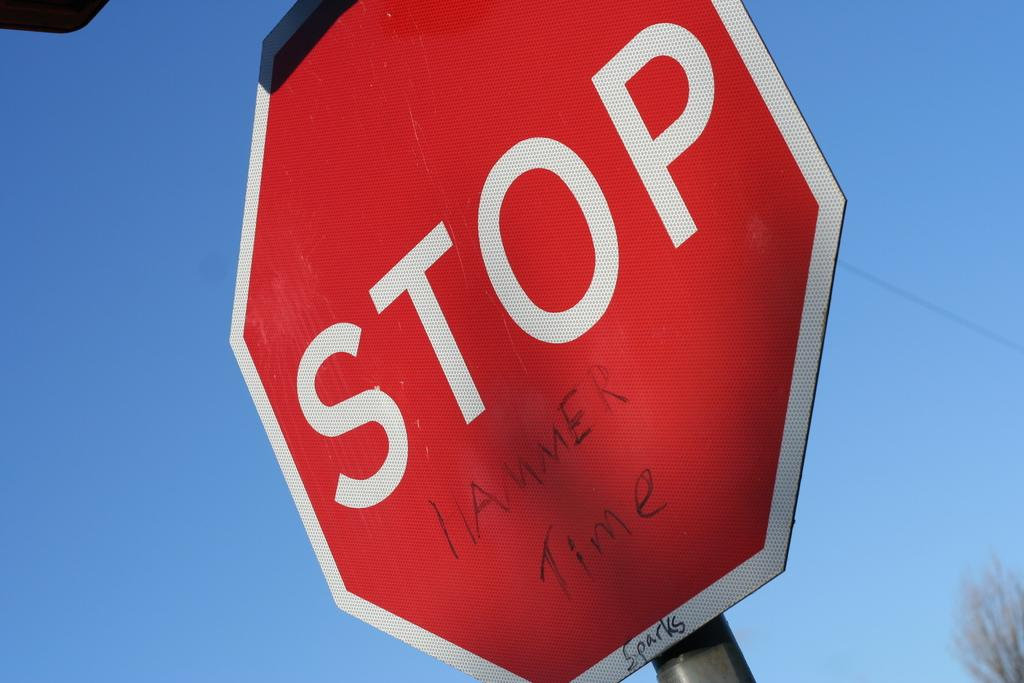<image>
Create a compact narrative representing the image presented. A STOP sign with graffiti etched underneath that says Hammer Time. 